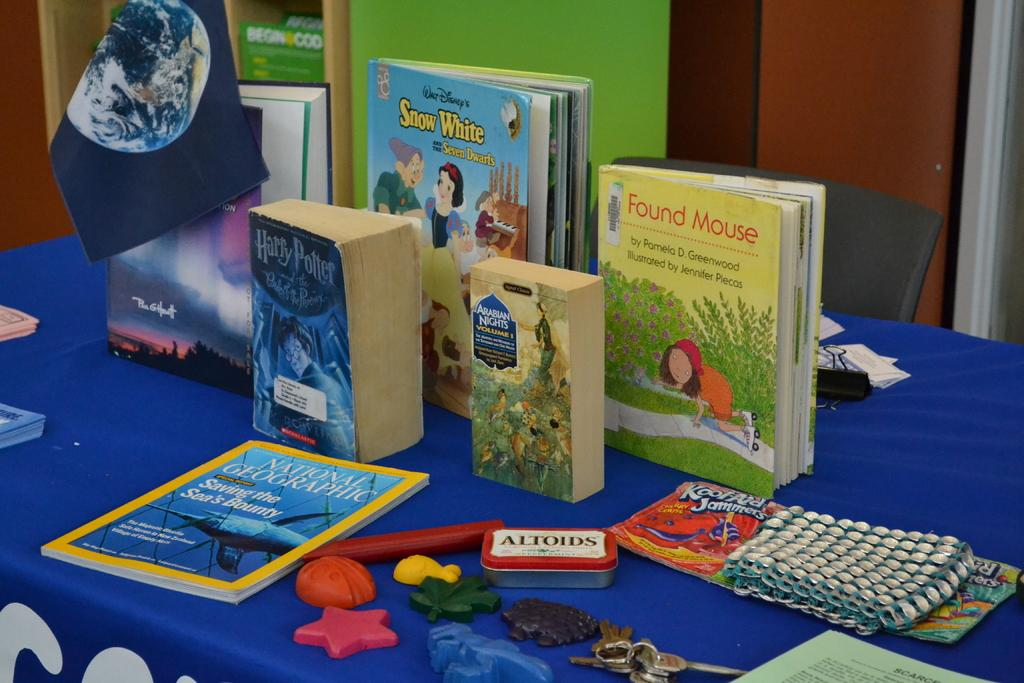<image>
Share a concise interpretation of the image provided. Books are on a table with a container of Altoids in the middle. 